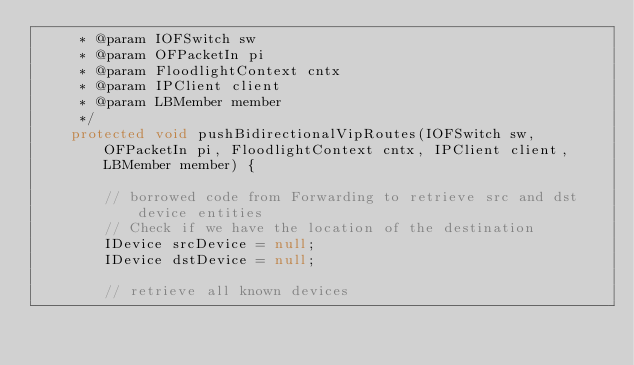Convert code to text. <code><loc_0><loc_0><loc_500><loc_500><_Java_>     * @param IOFSwitch sw
     * @param OFPacketIn pi
     * @param FloodlightContext cntx
     * @param IPClient client
     * @param LBMember member
     */
    protected void pushBidirectionalVipRoutes(IOFSwitch sw, OFPacketIn pi, FloodlightContext cntx, IPClient client, LBMember member) {
        
        // borrowed code from Forwarding to retrieve src and dst device entities
        // Check if we have the location of the destination
        IDevice srcDevice = null;
        IDevice dstDevice = null;
        
        // retrieve all known devices</code> 